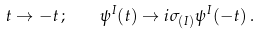Convert formula to latex. <formula><loc_0><loc_0><loc_500><loc_500>t \to - t \, ; \quad \psi ^ { I } ( t ) \to i \sigma _ { ( I ) } \psi ^ { I } ( - t ) \, .</formula> 